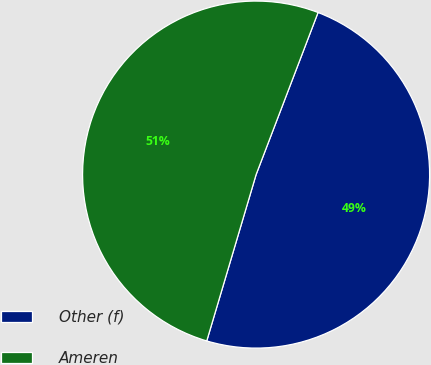Convert chart to OTSL. <chart><loc_0><loc_0><loc_500><loc_500><pie_chart><fcel>Other (f)<fcel>Ameren<nl><fcel>48.78%<fcel>51.22%<nl></chart> 